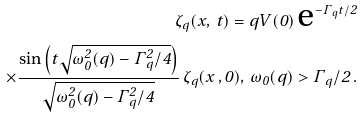Convert formula to latex. <formula><loc_0><loc_0><loc_500><loc_500>\zeta _ { q } ( x , \, t ) = q V ( 0 ) \, \text {e} ^ { - \Gamma _ { q } t / 2 } \\ \times \frac { \sin \left ( t \sqrt { \omega _ { 0 } ^ { 2 } ( q ) - \Gamma _ { q } ^ { 2 } / 4 } \right ) } { \sqrt { \omega _ { 0 } ^ { 2 } ( q ) - \Gamma _ { q } ^ { 2 } / 4 } } \, \zeta _ { q } ( x \, , 0 ) , \, \omega _ { 0 } ( q ) > \Gamma _ { q } / 2 \, .</formula> 